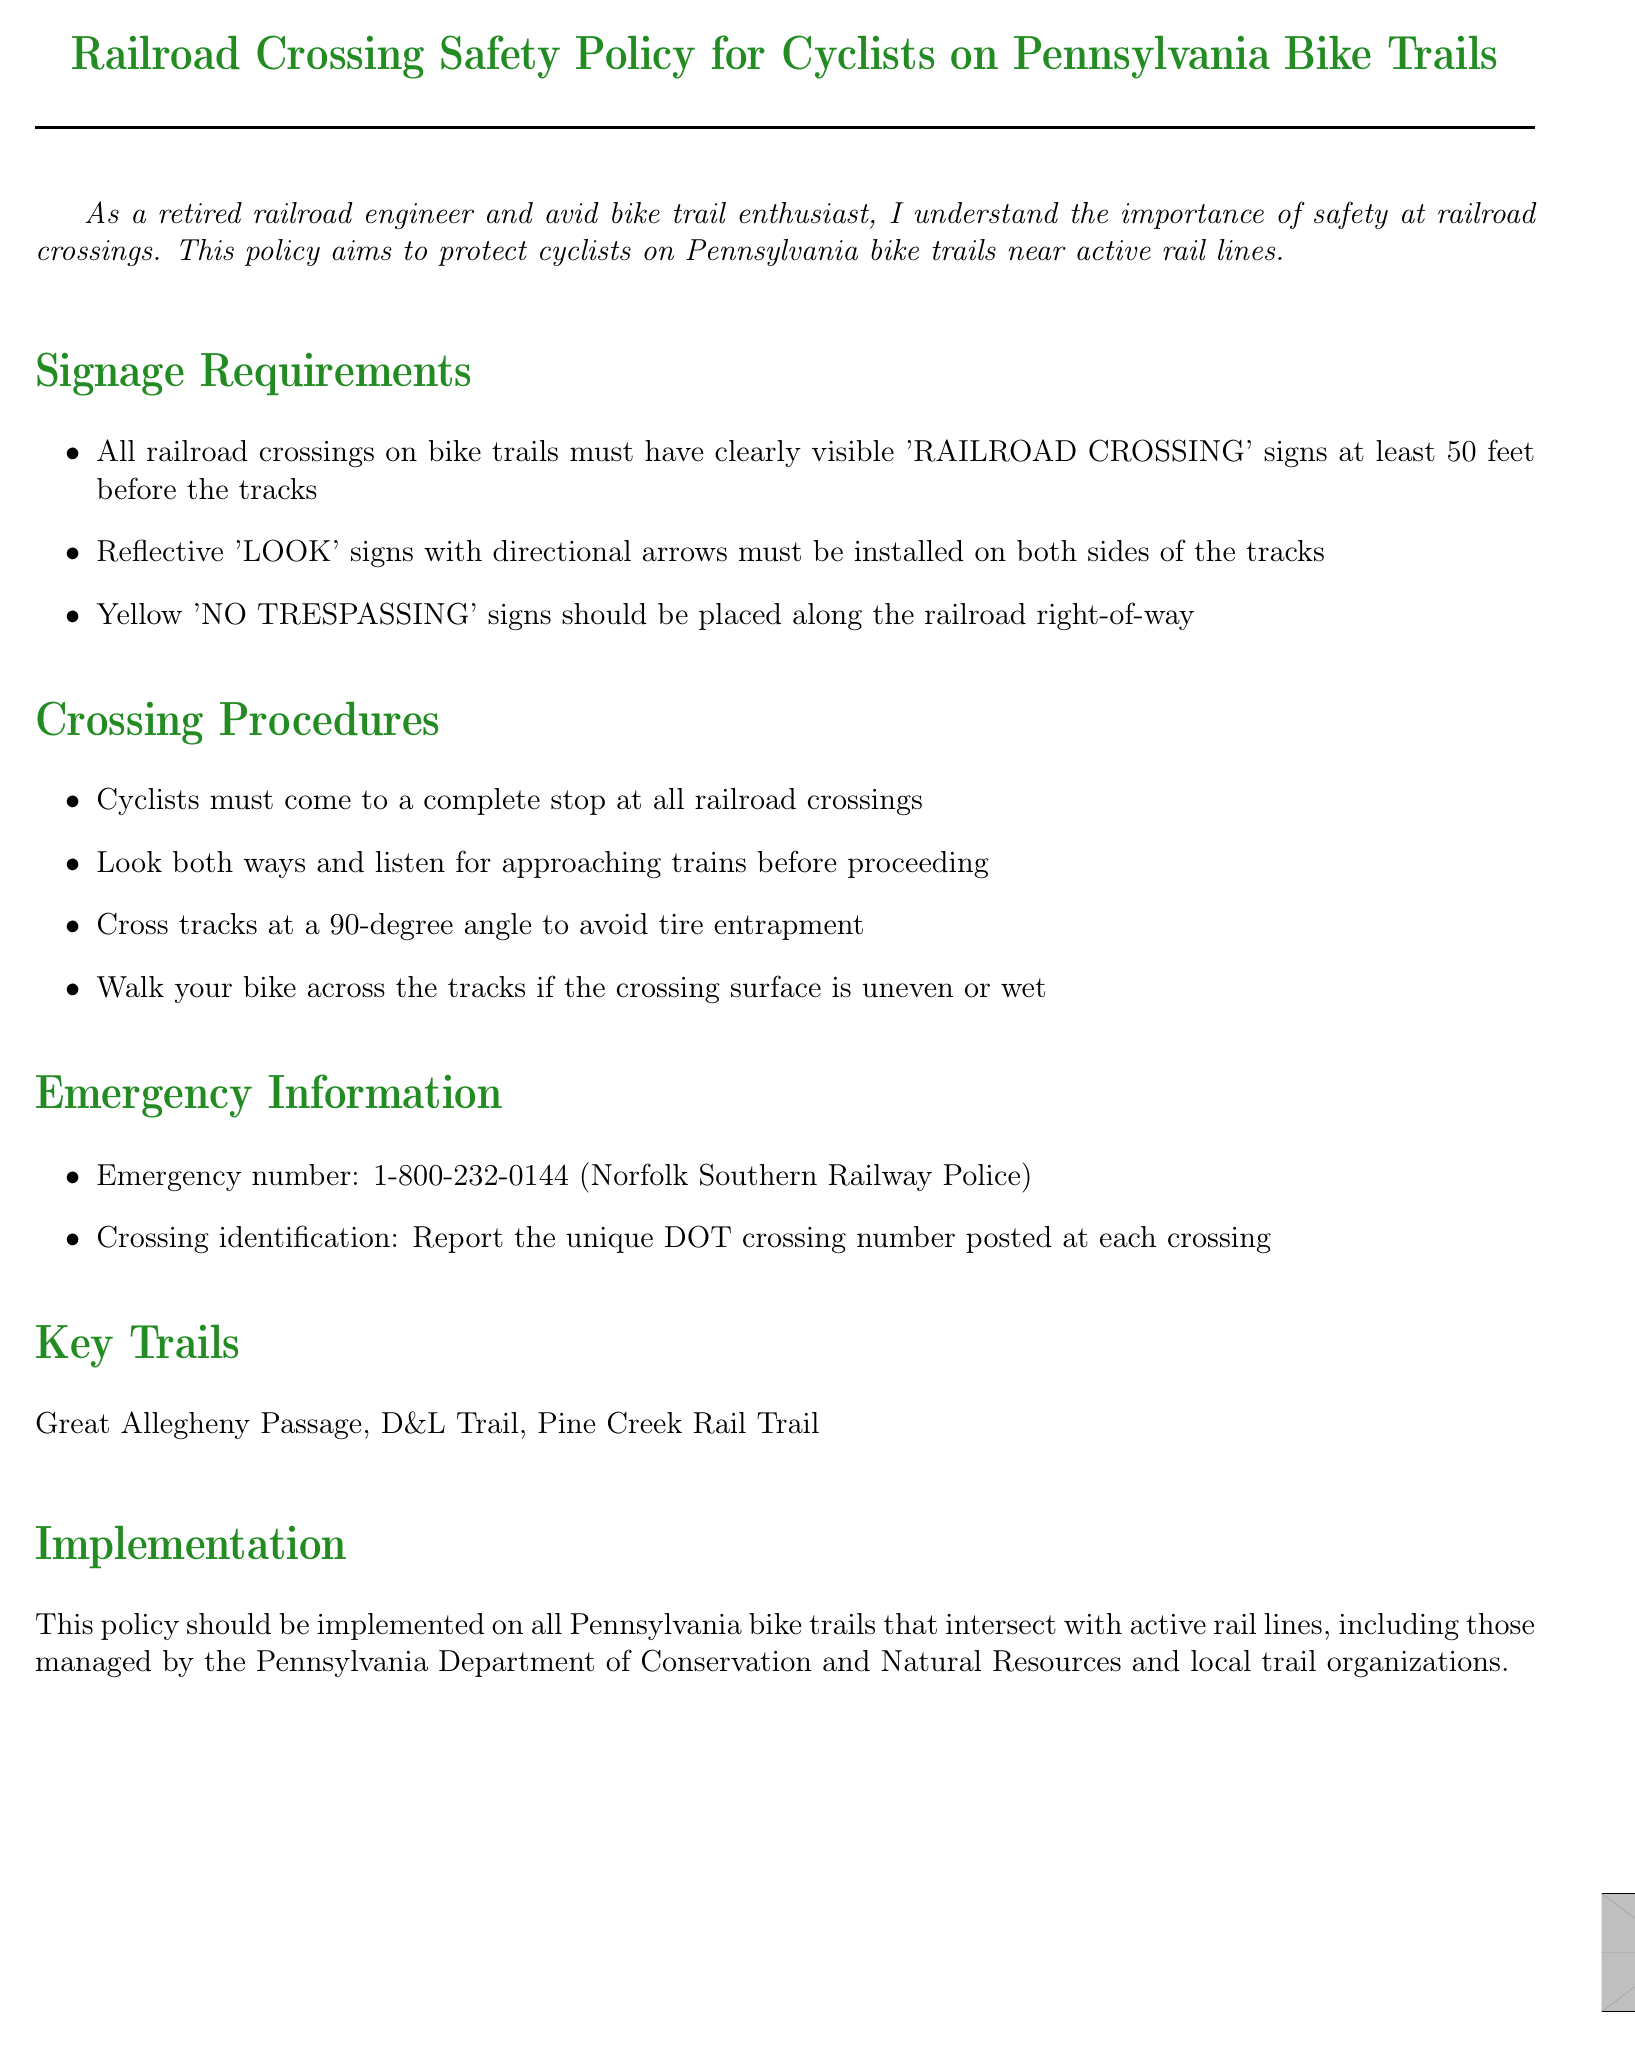What must cyclists do at railroad crossings? Cyclists are required to come to a complete stop at all railroad crossings, as stated in the Crossing Procedures section.
Answer: complete stop What signage is required before the tracks? The document specifies that all railroad crossings must have 'RAILROAD CROSSING' signs at least 50 feet before the tracks.
Answer: 50 feet What should cyclists do if the crossing surface is uneven? The policy states that cyclists should walk their bike across the tracks if the crossing surface is uneven or wet.
Answer: walk What is the emergency number provided in the document? The emergency information section provides a specific number for Norfolk Southern Railway Police which is 1-800-232-0144.
Answer: 1-800-232-0144 How should cyclists cross the tracks? Cyclists must cross tracks at a 90-degree angle to avoid tire entrapment, as required in the crossing procedures.
Answer: 90-degree angle What trails are mentioned as key trails in the document? The document lists Great Allegheny Passage, D&L Trail, and Pine Creek Rail Trail as key trails.
Answer: Great Allegheny Passage, D&L Trail, Pine Creek Rail Trail What type of signs should be placed along the railroad right-of-way? The document specifies that yellow 'NO TRESPASSING' signs should be placed along the railroad right-of-way.
Answer: NO TRESPASSING Who is responsible for implementing this policy? The implementation section indicates that the Pennsylvania Department of Conservation and Natural Resources and local trail organizations are responsible for the policy implementation.
Answer: Pennsylvania Department of Conservation and Natural Resources and local trail organizations 